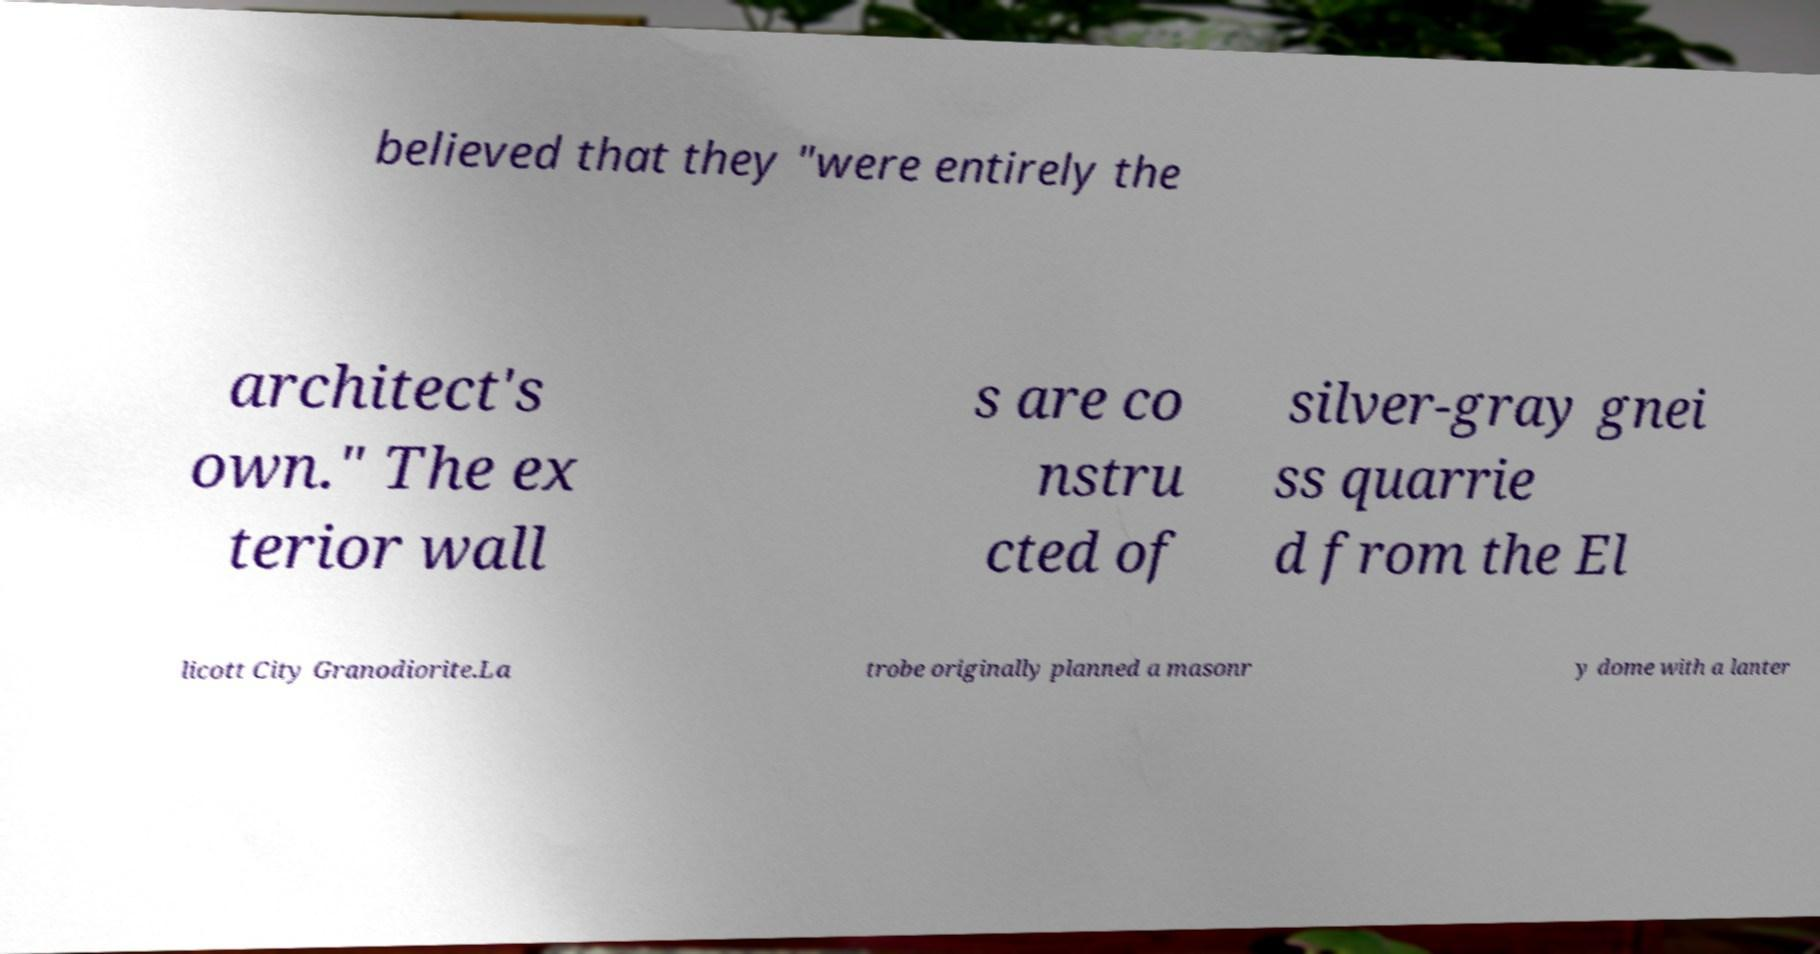What messages or text are displayed in this image? I need them in a readable, typed format. believed that they "were entirely the architect's own." The ex terior wall s are co nstru cted of silver-gray gnei ss quarrie d from the El licott City Granodiorite.La trobe originally planned a masonr y dome with a lanter 